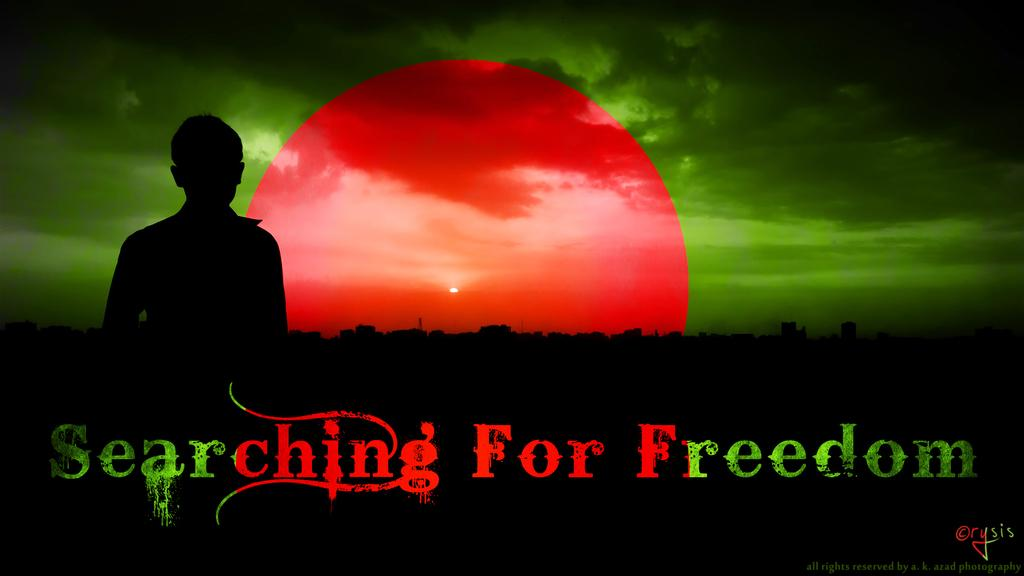<image>
Write a terse but informative summary of the picture. Screen showing a shadow in front of a red moon that says Searching for Freedom. 